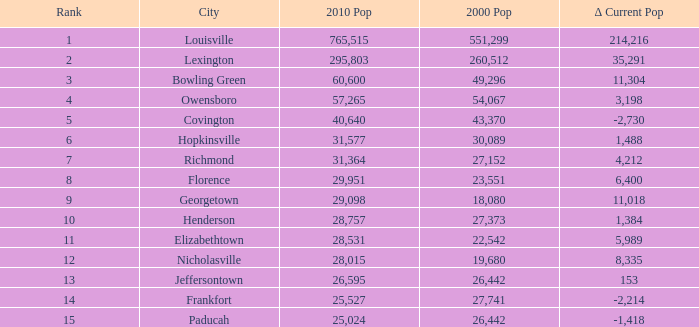Could you parse the entire table? {'header': ['Rank', 'City', '2010 Pop', '2000 Pop', 'Δ Current Pop'], 'rows': [['1', 'Louisville', '765,515', '551,299', '214,216'], ['2', 'Lexington', '295,803', '260,512', '35,291'], ['3', 'Bowling Green', '60,600', '49,296', '11,304'], ['4', 'Owensboro', '57,265', '54,067', '3,198'], ['5', 'Covington', '40,640', '43,370', '-2,730'], ['6', 'Hopkinsville', '31,577', '30,089', '1,488'], ['7', 'Richmond', '31,364', '27,152', '4,212'], ['8', 'Florence', '29,951', '23,551', '6,400'], ['9', 'Georgetown', '29,098', '18,080', '11,018'], ['10', 'Henderson', '28,757', '27,373', '1,384'], ['11', 'Elizabethtown', '28,531', '22,542', '5,989'], ['12', 'Nicholasville', '28,015', '19,680', '8,335'], ['13', 'Jeffersontown', '26,595', '26,442', '153'], ['14', 'Frankfort', '25,527', '27,741', '-2,214'], ['15', 'Paducah', '25,024', '26,442', '-1,418']]} What was the 2010 population of frankfort having a rank below 14? None. 